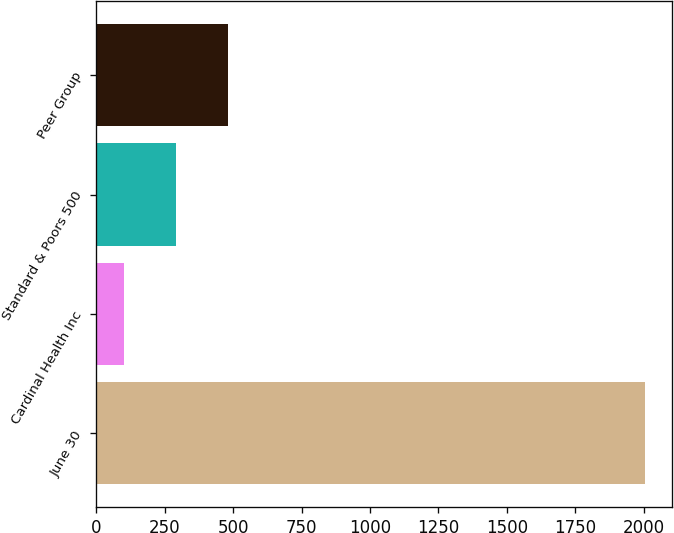Convert chart. <chart><loc_0><loc_0><loc_500><loc_500><bar_chart><fcel>June 30<fcel>Cardinal Health Inc<fcel>Standard & Poors 500<fcel>Peer Group<nl><fcel>2005<fcel>100<fcel>290.5<fcel>481<nl></chart> 